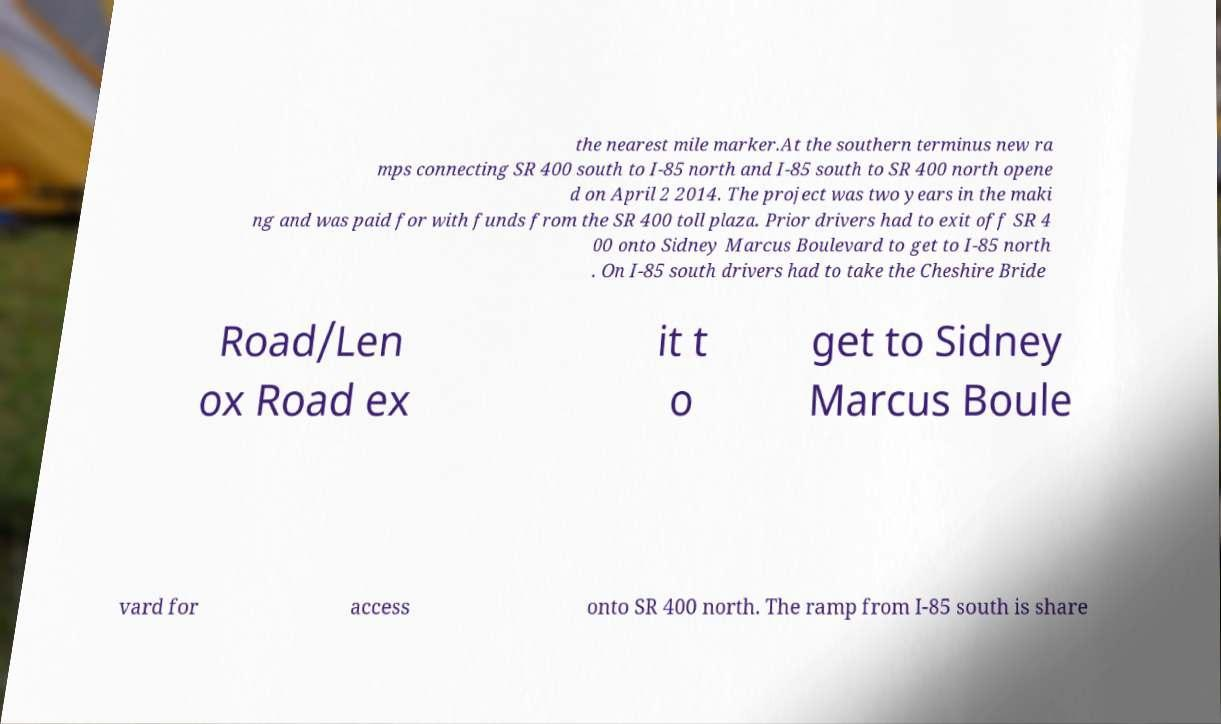I need the written content from this picture converted into text. Can you do that? the nearest mile marker.At the southern terminus new ra mps connecting SR 400 south to I-85 north and I-85 south to SR 400 north opene d on April 2 2014. The project was two years in the maki ng and was paid for with funds from the SR 400 toll plaza. Prior drivers had to exit off SR 4 00 onto Sidney Marcus Boulevard to get to I-85 north . On I-85 south drivers had to take the Cheshire Bride Road/Len ox Road ex it t o get to Sidney Marcus Boule vard for access onto SR 400 north. The ramp from I-85 south is share 